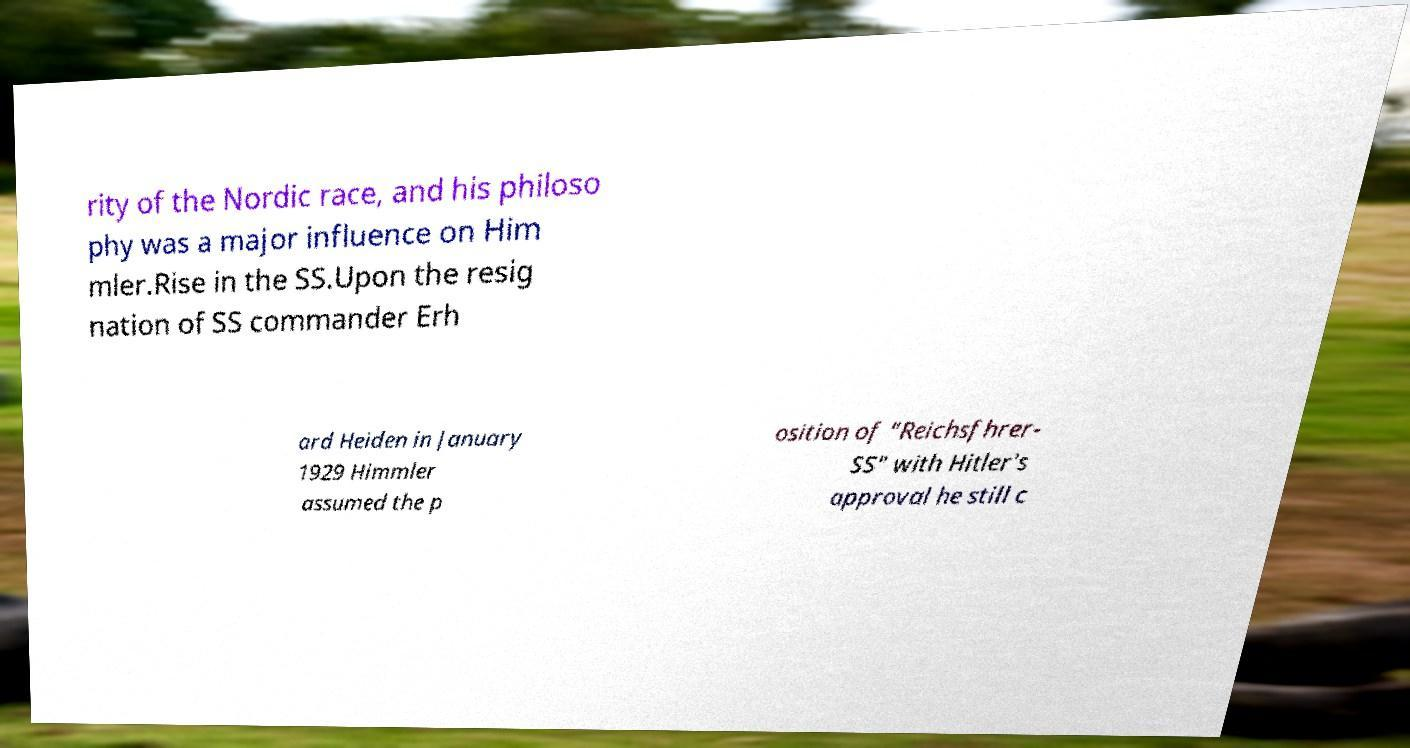Can you read and provide the text displayed in the image?This photo seems to have some interesting text. Can you extract and type it out for me? rity of the Nordic race, and his philoso phy was a major influence on Him mler.Rise in the SS.Upon the resig nation of SS commander Erh ard Heiden in January 1929 Himmler assumed the p osition of "Reichsfhrer- SS" with Hitler's approval he still c 